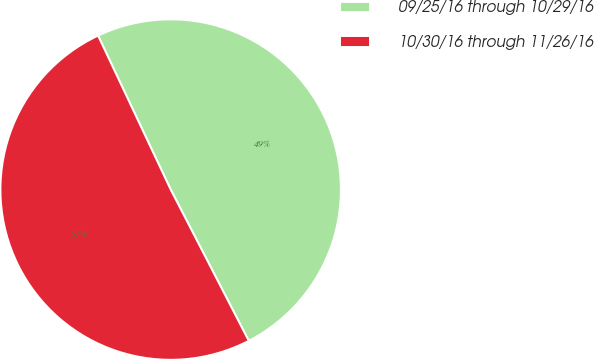Convert chart to OTSL. <chart><loc_0><loc_0><loc_500><loc_500><pie_chart><fcel>09/25/16 through 10/29/16<fcel>10/30/16 through 11/26/16<nl><fcel>49.43%<fcel>50.57%<nl></chart> 